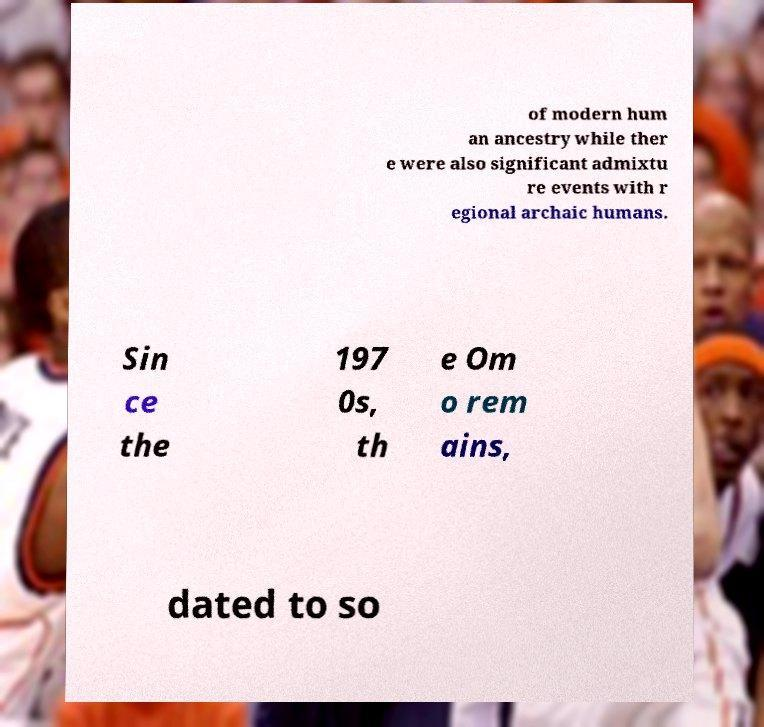Please read and relay the text visible in this image. What does it say? of modern hum an ancestry while ther e were also significant admixtu re events with r egional archaic humans. Sin ce the 197 0s, th e Om o rem ains, dated to so 